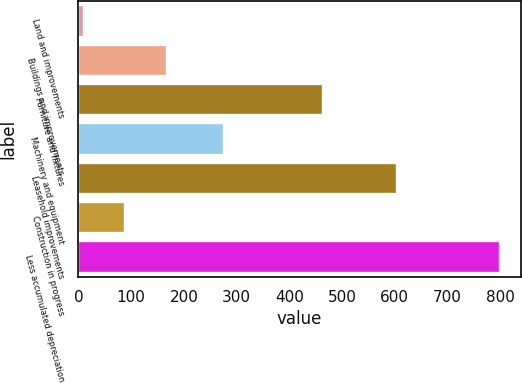<chart> <loc_0><loc_0><loc_500><loc_500><bar_chart><fcel>Land and improvements<fcel>Buildings and improvements<fcel>Furniture and fixtures<fcel>Machinery and equipment<fcel>Leasehold improvements<fcel>Construction in progress<fcel>Less accumulated depreciation<nl><fcel>9.9<fcel>167.84<fcel>464<fcel>276.9<fcel>604.6<fcel>88.87<fcel>799.6<nl></chart> 